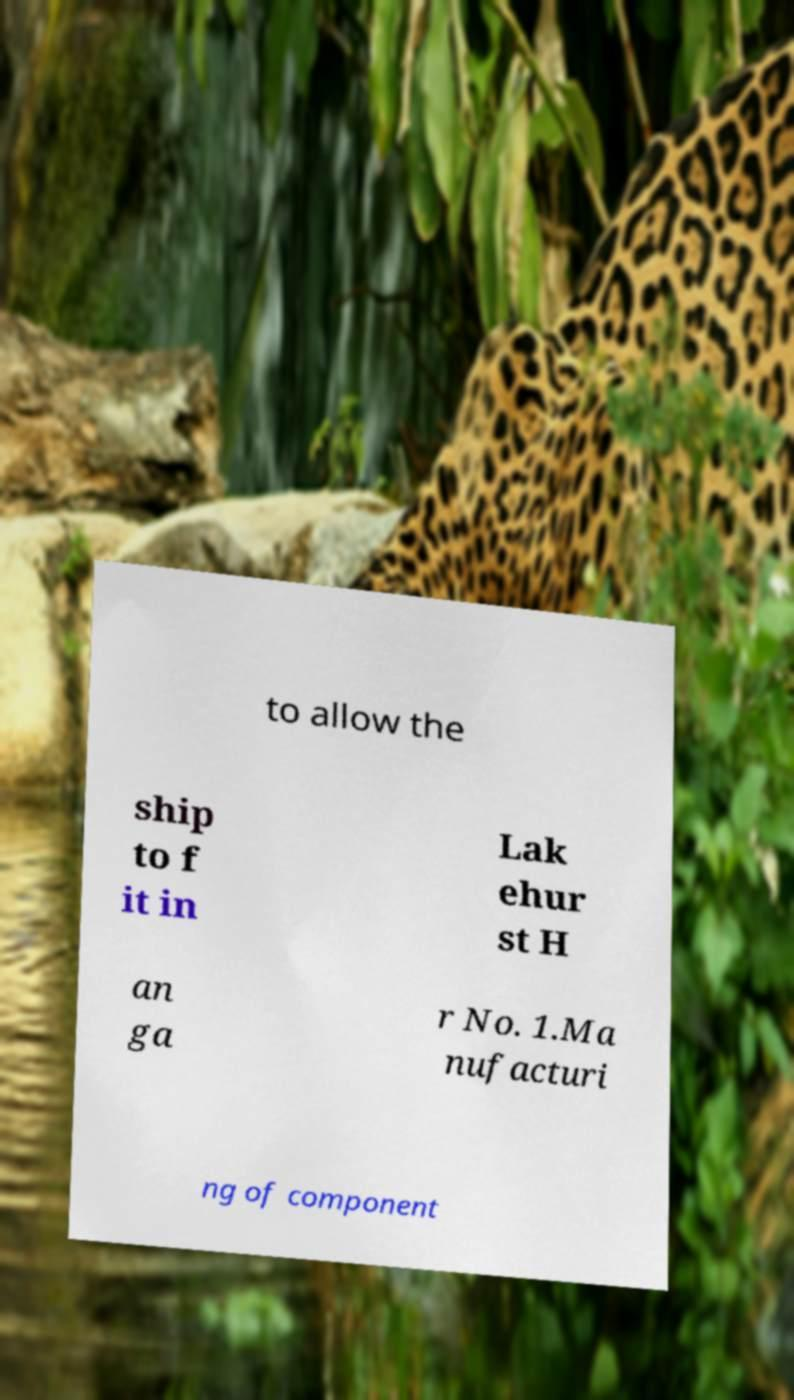There's text embedded in this image that I need extracted. Can you transcribe it verbatim? to allow the ship to f it in Lak ehur st H an ga r No. 1.Ma nufacturi ng of component 